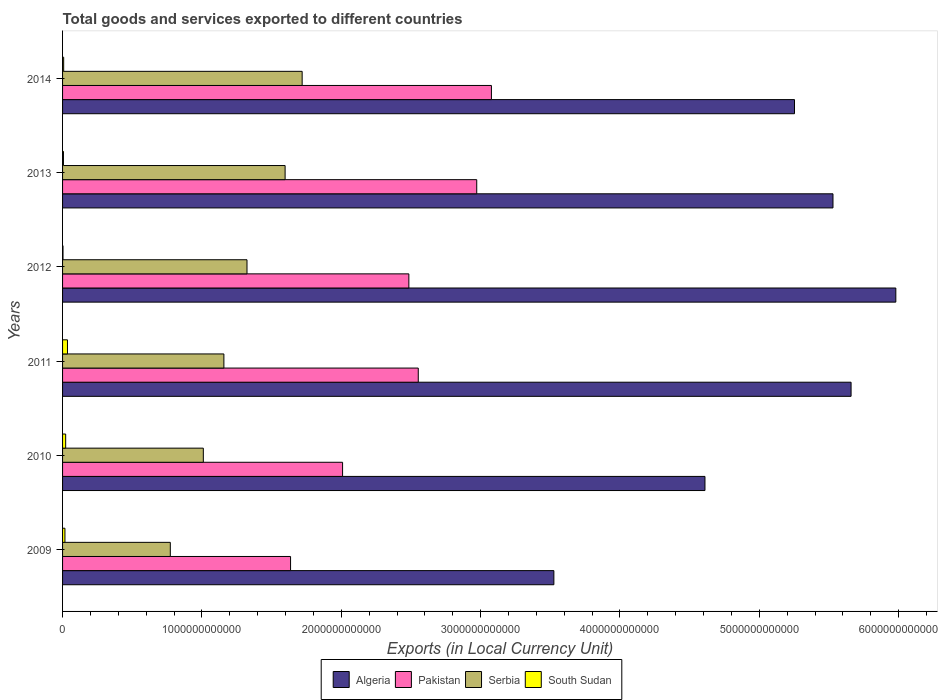How many different coloured bars are there?
Provide a short and direct response. 4. How many groups of bars are there?
Keep it short and to the point. 6. Are the number of bars per tick equal to the number of legend labels?
Your answer should be very brief. Yes. Are the number of bars on each tick of the Y-axis equal?
Ensure brevity in your answer.  Yes. How many bars are there on the 1st tick from the top?
Keep it short and to the point. 4. What is the label of the 6th group of bars from the top?
Make the answer very short. 2009. In how many cases, is the number of bars for a given year not equal to the number of legend labels?
Provide a succinct answer. 0. What is the Amount of goods and services exports in South Sudan in 2014?
Provide a short and direct response. 7.90e+09. Across all years, what is the maximum Amount of goods and services exports in Algeria?
Ensure brevity in your answer.  5.98e+12. Across all years, what is the minimum Amount of goods and services exports in South Sudan?
Your answer should be very brief. 3.10e+09. In which year was the Amount of goods and services exports in Serbia minimum?
Give a very brief answer. 2009. What is the total Amount of goods and services exports in Algeria in the graph?
Give a very brief answer. 3.06e+13. What is the difference between the Amount of goods and services exports in Pakistan in 2009 and that in 2014?
Provide a short and direct response. -1.44e+12. What is the difference between the Amount of goods and services exports in South Sudan in 2013 and the Amount of goods and services exports in Serbia in 2012?
Offer a very short reply. -1.32e+12. What is the average Amount of goods and services exports in Pakistan per year?
Provide a short and direct response. 2.46e+12. In the year 2009, what is the difference between the Amount of goods and services exports in Algeria and Amount of goods and services exports in Pakistan?
Give a very brief answer. 1.89e+12. What is the ratio of the Amount of goods and services exports in South Sudan in 2011 to that in 2014?
Your response must be concise. 4.46. Is the difference between the Amount of goods and services exports in Algeria in 2010 and 2013 greater than the difference between the Amount of goods and services exports in Pakistan in 2010 and 2013?
Your response must be concise. Yes. What is the difference between the highest and the second highest Amount of goods and services exports in Serbia?
Your answer should be compact. 1.22e+11. What is the difference between the highest and the lowest Amount of goods and services exports in South Sudan?
Keep it short and to the point. 3.21e+1. In how many years, is the Amount of goods and services exports in South Sudan greater than the average Amount of goods and services exports in South Sudan taken over all years?
Provide a short and direct response. 3. Is it the case that in every year, the sum of the Amount of goods and services exports in Pakistan and Amount of goods and services exports in Algeria is greater than the sum of Amount of goods and services exports in Serbia and Amount of goods and services exports in South Sudan?
Keep it short and to the point. Yes. What does the 1st bar from the top in 2010 represents?
Give a very brief answer. South Sudan. What does the 1st bar from the bottom in 2009 represents?
Offer a very short reply. Algeria. How many bars are there?
Keep it short and to the point. 24. How many years are there in the graph?
Your answer should be compact. 6. What is the difference between two consecutive major ticks on the X-axis?
Provide a short and direct response. 1.00e+12. Are the values on the major ticks of X-axis written in scientific E-notation?
Your answer should be compact. No. Does the graph contain any zero values?
Make the answer very short. No. Does the graph contain grids?
Your answer should be very brief. No. Where does the legend appear in the graph?
Give a very brief answer. Bottom center. How are the legend labels stacked?
Give a very brief answer. Horizontal. What is the title of the graph?
Ensure brevity in your answer.  Total goods and services exported to different countries. What is the label or title of the X-axis?
Your response must be concise. Exports (in Local Currency Unit). What is the label or title of the Y-axis?
Your answer should be compact. Years. What is the Exports (in Local Currency Unit) of Algeria in 2009?
Provide a succinct answer. 3.53e+12. What is the Exports (in Local Currency Unit) in Pakistan in 2009?
Your response must be concise. 1.64e+12. What is the Exports (in Local Currency Unit) in Serbia in 2009?
Your answer should be compact. 7.73e+11. What is the Exports (in Local Currency Unit) of South Sudan in 2009?
Your response must be concise. 1.70e+1. What is the Exports (in Local Currency Unit) in Algeria in 2010?
Your answer should be very brief. 4.61e+12. What is the Exports (in Local Currency Unit) in Pakistan in 2010?
Your answer should be very brief. 2.01e+12. What is the Exports (in Local Currency Unit) in Serbia in 2010?
Make the answer very short. 1.01e+12. What is the Exports (in Local Currency Unit) of South Sudan in 2010?
Provide a short and direct response. 2.23e+1. What is the Exports (in Local Currency Unit) in Algeria in 2011?
Make the answer very short. 5.66e+12. What is the Exports (in Local Currency Unit) of Pakistan in 2011?
Keep it short and to the point. 2.55e+12. What is the Exports (in Local Currency Unit) in Serbia in 2011?
Your answer should be very brief. 1.16e+12. What is the Exports (in Local Currency Unit) of South Sudan in 2011?
Make the answer very short. 3.52e+1. What is the Exports (in Local Currency Unit) of Algeria in 2012?
Give a very brief answer. 5.98e+12. What is the Exports (in Local Currency Unit) in Pakistan in 2012?
Offer a very short reply. 2.49e+12. What is the Exports (in Local Currency Unit) of Serbia in 2012?
Provide a succinct answer. 1.32e+12. What is the Exports (in Local Currency Unit) of South Sudan in 2012?
Provide a short and direct response. 3.10e+09. What is the Exports (in Local Currency Unit) in Algeria in 2013?
Offer a terse response. 5.53e+12. What is the Exports (in Local Currency Unit) of Pakistan in 2013?
Make the answer very short. 2.97e+12. What is the Exports (in Local Currency Unit) in Serbia in 2013?
Keep it short and to the point. 1.60e+12. What is the Exports (in Local Currency Unit) of South Sudan in 2013?
Make the answer very short. 6.33e+09. What is the Exports (in Local Currency Unit) of Algeria in 2014?
Your answer should be compact. 5.25e+12. What is the Exports (in Local Currency Unit) of Pakistan in 2014?
Make the answer very short. 3.08e+12. What is the Exports (in Local Currency Unit) of Serbia in 2014?
Ensure brevity in your answer.  1.72e+12. What is the Exports (in Local Currency Unit) of South Sudan in 2014?
Your answer should be compact. 7.90e+09. Across all years, what is the maximum Exports (in Local Currency Unit) in Algeria?
Keep it short and to the point. 5.98e+12. Across all years, what is the maximum Exports (in Local Currency Unit) in Pakistan?
Offer a very short reply. 3.08e+12. Across all years, what is the maximum Exports (in Local Currency Unit) in Serbia?
Give a very brief answer. 1.72e+12. Across all years, what is the maximum Exports (in Local Currency Unit) of South Sudan?
Offer a terse response. 3.52e+1. Across all years, what is the minimum Exports (in Local Currency Unit) in Algeria?
Your answer should be compact. 3.53e+12. Across all years, what is the minimum Exports (in Local Currency Unit) in Pakistan?
Your answer should be compact. 1.64e+12. Across all years, what is the minimum Exports (in Local Currency Unit) of Serbia?
Make the answer very short. 7.73e+11. Across all years, what is the minimum Exports (in Local Currency Unit) in South Sudan?
Provide a succinct answer. 3.10e+09. What is the total Exports (in Local Currency Unit) in Algeria in the graph?
Your answer should be very brief. 3.06e+13. What is the total Exports (in Local Currency Unit) of Pakistan in the graph?
Your answer should be compact. 1.47e+13. What is the total Exports (in Local Currency Unit) of Serbia in the graph?
Your answer should be compact. 7.58e+12. What is the total Exports (in Local Currency Unit) in South Sudan in the graph?
Provide a short and direct response. 9.18e+1. What is the difference between the Exports (in Local Currency Unit) of Algeria in 2009 and that in 2010?
Keep it short and to the point. -1.08e+12. What is the difference between the Exports (in Local Currency Unit) of Pakistan in 2009 and that in 2010?
Offer a very short reply. -3.73e+11. What is the difference between the Exports (in Local Currency Unit) of Serbia in 2009 and that in 2010?
Offer a terse response. -2.37e+11. What is the difference between the Exports (in Local Currency Unit) of South Sudan in 2009 and that in 2010?
Give a very brief answer. -5.23e+09. What is the difference between the Exports (in Local Currency Unit) in Algeria in 2009 and that in 2011?
Your answer should be very brief. -2.13e+12. What is the difference between the Exports (in Local Currency Unit) in Pakistan in 2009 and that in 2011?
Make the answer very short. -9.16e+11. What is the difference between the Exports (in Local Currency Unit) in Serbia in 2009 and that in 2011?
Your answer should be compact. -3.85e+11. What is the difference between the Exports (in Local Currency Unit) of South Sudan in 2009 and that in 2011?
Provide a succinct answer. -1.82e+1. What is the difference between the Exports (in Local Currency Unit) of Algeria in 2009 and that in 2012?
Your response must be concise. -2.45e+12. What is the difference between the Exports (in Local Currency Unit) of Pakistan in 2009 and that in 2012?
Your response must be concise. -8.49e+11. What is the difference between the Exports (in Local Currency Unit) of Serbia in 2009 and that in 2012?
Your answer should be very brief. -5.50e+11. What is the difference between the Exports (in Local Currency Unit) in South Sudan in 2009 and that in 2012?
Ensure brevity in your answer.  1.39e+1. What is the difference between the Exports (in Local Currency Unit) in Algeria in 2009 and that in 2013?
Your response must be concise. -2.00e+12. What is the difference between the Exports (in Local Currency Unit) of Pakistan in 2009 and that in 2013?
Offer a very short reply. -1.34e+12. What is the difference between the Exports (in Local Currency Unit) in Serbia in 2009 and that in 2013?
Provide a short and direct response. -8.24e+11. What is the difference between the Exports (in Local Currency Unit) of South Sudan in 2009 and that in 2013?
Your response must be concise. 1.07e+1. What is the difference between the Exports (in Local Currency Unit) of Algeria in 2009 and that in 2014?
Provide a succinct answer. -1.73e+12. What is the difference between the Exports (in Local Currency Unit) in Pakistan in 2009 and that in 2014?
Your answer should be compact. -1.44e+12. What is the difference between the Exports (in Local Currency Unit) in Serbia in 2009 and that in 2014?
Your answer should be compact. -9.46e+11. What is the difference between the Exports (in Local Currency Unit) of South Sudan in 2009 and that in 2014?
Offer a very short reply. 9.14e+09. What is the difference between the Exports (in Local Currency Unit) of Algeria in 2010 and that in 2011?
Ensure brevity in your answer.  -1.05e+12. What is the difference between the Exports (in Local Currency Unit) of Pakistan in 2010 and that in 2011?
Provide a succinct answer. -5.43e+11. What is the difference between the Exports (in Local Currency Unit) of Serbia in 2010 and that in 2011?
Give a very brief answer. -1.48e+11. What is the difference between the Exports (in Local Currency Unit) of South Sudan in 2010 and that in 2011?
Provide a succinct answer. -1.29e+1. What is the difference between the Exports (in Local Currency Unit) in Algeria in 2010 and that in 2012?
Offer a very short reply. -1.37e+12. What is the difference between the Exports (in Local Currency Unit) in Pakistan in 2010 and that in 2012?
Keep it short and to the point. -4.76e+11. What is the difference between the Exports (in Local Currency Unit) in Serbia in 2010 and that in 2012?
Provide a succinct answer. -3.13e+11. What is the difference between the Exports (in Local Currency Unit) of South Sudan in 2010 and that in 2012?
Ensure brevity in your answer.  1.92e+1. What is the difference between the Exports (in Local Currency Unit) of Algeria in 2010 and that in 2013?
Make the answer very short. -9.19e+11. What is the difference between the Exports (in Local Currency Unit) of Pakistan in 2010 and that in 2013?
Offer a terse response. -9.63e+11. What is the difference between the Exports (in Local Currency Unit) of Serbia in 2010 and that in 2013?
Provide a short and direct response. -5.87e+11. What is the difference between the Exports (in Local Currency Unit) of South Sudan in 2010 and that in 2013?
Provide a short and direct response. 1.59e+1. What is the difference between the Exports (in Local Currency Unit) of Algeria in 2010 and that in 2014?
Offer a very short reply. -6.42e+11. What is the difference between the Exports (in Local Currency Unit) in Pakistan in 2010 and that in 2014?
Make the answer very short. -1.07e+12. What is the difference between the Exports (in Local Currency Unit) of Serbia in 2010 and that in 2014?
Your response must be concise. -7.09e+11. What is the difference between the Exports (in Local Currency Unit) in South Sudan in 2010 and that in 2014?
Keep it short and to the point. 1.44e+1. What is the difference between the Exports (in Local Currency Unit) in Algeria in 2011 and that in 2012?
Provide a succinct answer. -3.21e+11. What is the difference between the Exports (in Local Currency Unit) in Pakistan in 2011 and that in 2012?
Provide a short and direct response. 6.75e+1. What is the difference between the Exports (in Local Currency Unit) in Serbia in 2011 and that in 2012?
Provide a succinct answer. -1.66e+11. What is the difference between the Exports (in Local Currency Unit) of South Sudan in 2011 and that in 2012?
Your answer should be very brief. 3.21e+1. What is the difference between the Exports (in Local Currency Unit) in Algeria in 2011 and that in 2013?
Make the answer very short. 1.30e+11. What is the difference between the Exports (in Local Currency Unit) of Pakistan in 2011 and that in 2013?
Give a very brief answer. -4.20e+11. What is the difference between the Exports (in Local Currency Unit) of Serbia in 2011 and that in 2013?
Give a very brief answer. -4.39e+11. What is the difference between the Exports (in Local Currency Unit) of South Sudan in 2011 and that in 2013?
Your answer should be compact. 2.89e+1. What is the difference between the Exports (in Local Currency Unit) of Algeria in 2011 and that in 2014?
Your response must be concise. 4.06e+11. What is the difference between the Exports (in Local Currency Unit) in Pakistan in 2011 and that in 2014?
Provide a succinct answer. -5.25e+11. What is the difference between the Exports (in Local Currency Unit) in Serbia in 2011 and that in 2014?
Offer a very short reply. -5.62e+11. What is the difference between the Exports (in Local Currency Unit) in South Sudan in 2011 and that in 2014?
Your answer should be compact. 2.73e+1. What is the difference between the Exports (in Local Currency Unit) in Algeria in 2012 and that in 2013?
Keep it short and to the point. 4.51e+11. What is the difference between the Exports (in Local Currency Unit) in Pakistan in 2012 and that in 2013?
Offer a very short reply. -4.87e+11. What is the difference between the Exports (in Local Currency Unit) of Serbia in 2012 and that in 2013?
Your response must be concise. -2.73e+11. What is the difference between the Exports (in Local Currency Unit) of South Sudan in 2012 and that in 2013?
Provide a short and direct response. -3.24e+09. What is the difference between the Exports (in Local Currency Unit) in Algeria in 2012 and that in 2014?
Ensure brevity in your answer.  7.27e+11. What is the difference between the Exports (in Local Currency Unit) in Pakistan in 2012 and that in 2014?
Make the answer very short. -5.93e+11. What is the difference between the Exports (in Local Currency Unit) in Serbia in 2012 and that in 2014?
Your response must be concise. -3.96e+11. What is the difference between the Exports (in Local Currency Unit) of South Sudan in 2012 and that in 2014?
Provide a short and direct response. -4.80e+09. What is the difference between the Exports (in Local Currency Unit) of Algeria in 2013 and that in 2014?
Provide a succinct answer. 2.76e+11. What is the difference between the Exports (in Local Currency Unit) of Pakistan in 2013 and that in 2014?
Offer a very short reply. -1.05e+11. What is the difference between the Exports (in Local Currency Unit) of Serbia in 2013 and that in 2014?
Your response must be concise. -1.22e+11. What is the difference between the Exports (in Local Currency Unit) of South Sudan in 2013 and that in 2014?
Your response must be concise. -1.56e+09. What is the difference between the Exports (in Local Currency Unit) in Algeria in 2009 and the Exports (in Local Currency Unit) in Pakistan in 2010?
Give a very brief answer. 1.52e+12. What is the difference between the Exports (in Local Currency Unit) in Algeria in 2009 and the Exports (in Local Currency Unit) in Serbia in 2010?
Your response must be concise. 2.52e+12. What is the difference between the Exports (in Local Currency Unit) of Algeria in 2009 and the Exports (in Local Currency Unit) of South Sudan in 2010?
Provide a short and direct response. 3.50e+12. What is the difference between the Exports (in Local Currency Unit) in Pakistan in 2009 and the Exports (in Local Currency Unit) in Serbia in 2010?
Provide a short and direct response. 6.26e+11. What is the difference between the Exports (in Local Currency Unit) in Pakistan in 2009 and the Exports (in Local Currency Unit) in South Sudan in 2010?
Make the answer very short. 1.61e+12. What is the difference between the Exports (in Local Currency Unit) in Serbia in 2009 and the Exports (in Local Currency Unit) in South Sudan in 2010?
Your answer should be compact. 7.51e+11. What is the difference between the Exports (in Local Currency Unit) in Algeria in 2009 and the Exports (in Local Currency Unit) in Pakistan in 2011?
Your answer should be very brief. 9.73e+11. What is the difference between the Exports (in Local Currency Unit) of Algeria in 2009 and the Exports (in Local Currency Unit) of Serbia in 2011?
Provide a succinct answer. 2.37e+12. What is the difference between the Exports (in Local Currency Unit) in Algeria in 2009 and the Exports (in Local Currency Unit) in South Sudan in 2011?
Your answer should be compact. 3.49e+12. What is the difference between the Exports (in Local Currency Unit) of Pakistan in 2009 and the Exports (in Local Currency Unit) of Serbia in 2011?
Give a very brief answer. 4.78e+11. What is the difference between the Exports (in Local Currency Unit) in Pakistan in 2009 and the Exports (in Local Currency Unit) in South Sudan in 2011?
Your answer should be very brief. 1.60e+12. What is the difference between the Exports (in Local Currency Unit) of Serbia in 2009 and the Exports (in Local Currency Unit) of South Sudan in 2011?
Keep it short and to the point. 7.38e+11. What is the difference between the Exports (in Local Currency Unit) of Algeria in 2009 and the Exports (in Local Currency Unit) of Pakistan in 2012?
Make the answer very short. 1.04e+12. What is the difference between the Exports (in Local Currency Unit) of Algeria in 2009 and the Exports (in Local Currency Unit) of Serbia in 2012?
Provide a short and direct response. 2.20e+12. What is the difference between the Exports (in Local Currency Unit) in Algeria in 2009 and the Exports (in Local Currency Unit) in South Sudan in 2012?
Your answer should be very brief. 3.52e+12. What is the difference between the Exports (in Local Currency Unit) in Pakistan in 2009 and the Exports (in Local Currency Unit) in Serbia in 2012?
Provide a short and direct response. 3.13e+11. What is the difference between the Exports (in Local Currency Unit) of Pakistan in 2009 and the Exports (in Local Currency Unit) of South Sudan in 2012?
Keep it short and to the point. 1.63e+12. What is the difference between the Exports (in Local Currency Unit) in Serbia in 2009 and the Exports (in Local Currency Unit) in South Sudan in 2012?
Offer a terse response. 7.70e+11. What is the difference between the Exports (in Local Currency Unit) of Algeria in 2009 and the Exports (in Local Currency Unit) of Pakistan in 2013?
Keep it short and to the point. 5.54e+11. What is the difference between the Exports (in Local Currency Unit) of Algeria in 2009 and the Exports (in Local Currency Unit) of Serbia in 2013?
Offer a terse response. 1.93e+12. What is the difference between the Exports (in Local Currency Unit) in Algeria in 2009 and the Exports (in Local Currency Unit) in South Sudan in 2013?
Provide a short and direct response. 3.52e+12. What is the difference between the Exports (in Local Currency Unit) in Pakistan in 2009 and the Exports (in Local Currency Unit) in Serbia in 2013?
Offer a terse response. 3.91e+1. What is the difference between the Exports (in Local Currency Unit) in Pakistan in 2009 and the Exports (in Local Currency Unit) in South Sudan in 2013?
Your answer should be very brief. 1.63e+12. What is the difference between the Exports (in Local Currency Unit) in Serbia in 2009 and the Exports (in Local Currency Unit) in South Sudan in 2013?
Provide a succinct answer. 7.67e+11. What is the difference between the Exports (in Local Currency Unit) in Algeria in 2009 and the Exports (in Local Currency Unit) in Pakistan in 2014?
Your answer should be compact. 4.48e+11. What is the difference between the Exports (in Local Currency Unit) in Algeria in 2009 and the Exports (in Local Currency Unit) in Serbia in 2014?
Give a very brief answer. 1.81e+12. What is the difference between the Exports (in Local Currency Unit) in Algeria in 2009 and the Exports (in Local Currency Unit) in South Sudan in 2014?
Keep it short and to the point. 3.52e+12. What is the difference between the Exports (in Local Currency Unit) in Pakistan in 2009 and the Exports (in Local Currency Unit) in Serbia in 2014?
Offer a very short reply. -8.31e+1. What is the difference between the Exports (in Local Currency Unit) of Pakistan in 2009 and the Exports (in Local Currency Unit) of South Sudan in 2014?
Your answer should be very brief. 1.63e+12. What is the difference between the Exports (in Local Currency Unit) of Serbia in 2009 and the Exports (in Local Currency Unit) of South Sudan in 2014?
Give a very brief answer. 7.65e+11. What is the difference between the Exports (in Local Currency Unit) of Algeria in 2010 and the Exports (in Local Currency Unit) of Pakistan in 2011?
Provide a succinct answer. 2.06e+12. What is the difference between the Exports (in Local Currency Unit) in Algeria in 2010 and the Exports (in Local Currency Unit) in Serbia in 2011?
Keep it short and to the point. 3.45e+12. What is the difference between the Exports (in Local Currency Unit) in Algeria in 2010 and the Exports (in Local Currency Unit) in South Sudan in 2011?
Ensure brevity in your answer.  4.57e+12. What is the difference between the Exports (in Local Currency Unit) in Pakistan in 2010 and the Exports (in Local Currency Unit) in Serbia in 2011?
Provide a short and direct response. 8.52e+11. What is the difference between the Exports (in Local Currency Unit) in Pakistan in 2010 and the Exports (in Local Currency Unit) in South Sudan in 2011?
Your answer should be very brief. 1.97e+12. What is the difference between the Exports (in Local Currency Unit) of Serbia in 2010 and the Exports (in Local Currency Unit) of South Sudan in 2011?
Offer a very short reply. 9.75e+11. What is the difference between the Exports (in Local Currency Unit) of Algeria in 2010 and the Exports (in Local Currency Unit) of Pakistan in 2012?
Provide a succinct answer. 2.13e+12. What is the difference between the Exports (in Local Currency Unit) of Algeria in 2010 and the Exports (in Local Currency Unit) of Serbia in 2012?
Make the answer very short. 3.29e+12. What is the difference between the Exports (in Local Currency Unit) of Algeria in 2010 and the Exports (in Local Currency Unit) of South Sudan in 2012?
Ensure brevity in your answer.  4.61e+12. What is the difference between the Exports (in Local Currency Unit) in Pakistan in 2010 and the Exports (in Local Currency Unit) in Serbia in 2012?
Provide a succinct answer. 6.86e+11. What is the difference between the Exports (in Local Currency Unit) of Pakistan in 2010 and the Exports (in Local Currency Unit) of South Sudan in 2012?
Keep it short and to the point. 2.01e+12. What is the difference between the Exports (in Local Currency Unit) of Serbia in 2010 and the Exports (in Local Currency Unit) of South Sudan in 2012?
Provide a short and direct response. 1.01e+12. What is the difference between the Exports (in Local Currency Unit) in Algeria in 2010 and the Exports (in Local Currency Unit) in Pakistan in 2013?
Make the answer very short. 1.64e+12. What is the difference between the Exports (in Local Currency Unit) of Algeria in 2010 and the Exports (in Local Currency Unit) of Serbia in 2013?
Offer a very short reply. 3.01e+12. What is the difference between the Exports (in Local Currency Unit) in Algeria in 2010 and the Exports (in Local Currency Unit) in South Sudan in 2013?
Give a very brief answer. 4.60e+12. What is the difference between the Exports (in Local Currency Unit) in Pakistan in 2010 and the Exports (in Local Currency Unit) in Serbia in 2013?
Offer a very short reply. 4.12e+11. What is the difference between the Exports (in Local Currency Unit) in Pakistan in 2010 and the Exports (in Local Currency Unit) in South Sudan in 2013?
Make the answer very short. 2.00e+12. What is the difference between the Exports (in Local Currency Unit) in Serbia in 2010 and the Exports (in Local Currency Unit) in South Sudan in 2013?
Your answer should be very brief. 1.00e+12. What is the difference between the Exports (in Local Currency Unit) in Algeria in 2010 and the Exports (in Local Currency Unit) in Pakistan in 2014?
Offer a terse response. 1.53e+12. What is the difference between the Exports (in Local Currency Unit) of Algeria in 2010 and the Exports (in Local Currency Unit) of Serbia in 2014?
Give a very brief answer. 2.89e+12. What is the difference between the Exports (in Local Currency Unit) of Algeria in 2010 and the Exports (in Local Currency Unit) of South Sudan in 2014?
Your response must be concise. 4.60e+12. What is the difference between the Exports (in Local Currency Unit) in Pakistan in 2010 and the Exports (in Local Currency Unit) in Serbia in 2014?
Provide a short and direct response. 2.90e+11. What is the difference between the Exports (in Local Currency Unit) of Pakistan in 2010 and the Exports (in Local Currency Unit) of South Sudan in 2014?
Offer a terse response. 2.00e+12. What is the difference between the Exports (in Local Currency Unit) of Serbia in 2010 and the Exports (in Local Currency Unit) of South Sudan in 2014?
Provide a short and direct response. 1.00e+12. What is the difference between the Exports (in Local Currency Unit) in Algeria in 2011 and the Exports (in Local Currency Unit) in Pakistan in 2012?
Offer a very short reply. 3.17e+12. What is the difference between the Exports (in Local Currency Unit) of Algeria in 2011 and the Exports (in Local Currency Unit) of Serbia in 2012?
Ensure brevity in your answer.  4.34e+12. What is the difference between the Exports (in Local Currency Unit) in Algeria in 2011 and the Exports (in Local Currency Unit) in South Sudan in 2012?
Provide a short and direct response. 5.66e+12. What is the difference between the Exports (in Local Currency Unit) in Pakistan in 2011 and the Exports (in Local Currency Unit) in Serbia in 2012?
Give a very brief answer. 1.23e+12. What is the difference between the Exports (in Local Currency Unit) of Pakistan in 2011 and the Exports (in Local Currency Unit) of South Sudan in 2012?
Offer a very short reply. 2.55e+12. What is the difference between the Exports (in Local Currency Unit) in Serbia in 2011 and the Exports (in Local Currency Unit) in South Sudan in 2012?
Your answer should be compact. 1.15e+12. What is the difference between the Exports (in Local Currency Unit) in Algeria in 2011 and the Exports (in Local Currency Unit) in Pakistan in 2013?
Offer a very short reply. 2.69e+12. What is the difference between the Exports (in Local Currency Unit) in Algeria in 2011 and the Exports (in Local Currency Unit) in Serbia in 2013?
Make the answer very short. 4.06e+12. What is the difference between the Exports (in Local Currency Unit) in Algeria in 2011 and the Exports (in Local Currency Unit) in South Sudan in 2013?
Give a very brief answer. 5.65e+12. What is the difference between the Exports (in Local Currency Unit) of Pakistan in 2011 and the Exports (in Local Currency Unit) of Serbia in 2013?
Offer a terse response. 9.56e+11. What is the difference between the Exports (in Local Currency Unit) of Pakistan in 2011 and the Exports (in Local Currency Unit) of South Sudan in 2013?
Provide a short and direct response. 2.55e+12. What is the difference between the Exports (in Local Currency Unit) of Serbia in 2011 and the Exports (in Local Currency Unit) of South Sudan in 2013?
Your answer should be compact. 1.15e+12. What is the difference between the Exports (in Local Currency Unit) in Algeria in 2011 and the Exports (in Local Currency Unit) in Pakistan in 2014?
Make the answer very short. 2.58e+12. What is the difference between the Exports (in Local Currency Unit) in Algeria in 2011 and the Exports (in Local Currency Unit) in Serbia in 2014?
Provide a succinct answer. 3.94e+12. What is the difference between the Exports (in Local Currency Unit) of Algeria in 2011 and the Exports (in Local Currency Unit) of South Sudan in 2014?
Your answer should be compact. 5.65e+12. What is the difference between the Exports (in Local Currency Unit) of Pakistan in 2011 and the Exports (in Local Currency Unit) of Serbia in 2014?
Ensure brevity in your answer.  8.33e+11. What is the difference between the Exports (in Local Currency Unit) of Pakistan in 2011 and the Exports (in Local Currency Unit) of South Sudan in 2014?
Keep it short and to the point. 2.54e+12. What is the difference between the Exports (in Local Currency Unit) of Serbia in 2011 and the Exports (in Local Currency Unit) of South Sudan in 2014?
Give a very brief answer. 1.15e+12. What is the difference between the Exports (in Local Currency Unit) in Algeria in 2012 and the Exports (in Local Currency Unit) in Pakistan in 2013?
Provide a succinct answer. 3.01e+12. What is the difference between the Exports (in Local Currency Unit) of Algeria in 2012 and the Exports (in Local Currency Unit) of Serbia in 2013?
Make the answer very short. 4.38e+12. What is the difference between the Exports (in Local Currency Unit) in Algeria in 2012 and the Exports (in Local Currency Unit) in South Sudan in 2013?
Keep it short and to the point. 5.97e+12. What is the difference between the Exports (in Local Currency Unit) of Pakistan in 2012 and the Exports (in Local Currency Unit) of Serbia in 2013?
Provide a succinct answer. 8.88e+11. What is the difference between the Exports (in Local Currency Unit) in Pakistan in 2012 and the Exports (in Local Currency Unit) in South Sudan in 2013?
Offer a very short reply. 2.48e+12. What is the difference between the Exports (in Local Currency Unit) of Serbia in 2012 and the Exports (in Local Currency Unit) of South Sudan in 2013?
Make the answer very short. 1.32e+12. What is the difference between the Exports (in Local Currency Unit) in Algeria in 2012 and the Exports (in Local Currency Unit) in Pakistan in 2014?
Ensure brevity in your answer.  2.90e+12. What is the difference between the Exports (in Local Currency Unit) in Algeria in 2012 and the Exports (in Local Currency Unit) in Serbia in 2014?
Your response must be concise. 4.26e+12. What is the difference between the Exports (in Local Currency Unit) in Algeria in 2012 and the Exports (in Local Currency Unit) in South Sudan in 2014?
Make the answer very short. 5.97e+12. What is the difference between the Exports (in Local Currency Unit) of Pakistan in 2012 and the Exports (in Local Currency Unit) of Serbia in 2014?
Give a very brief answer. 7.66e+11. What is the difference between the Exports (in Local Currency Unit) of Pakistan in 2012 and the Exports (in Local Currency Unit) of South Sudan in 2014?
Your response must be concise. 2.48e+12. What is the difference between the Exports (in Local Currency Unit) in Serbia in 2012 and the Exports (in Local Currency Unit) in South Sudan in 2014?
Offer a terse response. 1.32e+12. What is the difference between the Exports (in Local Currency Unit) of Algeria in 2013 and the Exports (in Local Currency Unit) of Pakistan in 2014?
Make the answer very short. 2.45e+12. What is the difference between the Exports (in Local Currency Unit) of Algeria in 2013 and the Exports (in Local Currency Unit) of Serbia in 2014?
Ensure brevity in your answer.  3.81e+12. What is the difference between the Exports (in Local Currency Unit) of Algeria in 2013 and the Exports (in Local Currency Unit) of South Sudan in 2014?
Your answer should be very brief. 5.52e+12. What is the difference between the Exports (in Local Currency Unit) of Pakistan in 2013 and the Exports (in Local Currency Unit) of Serbia in 2014?
Ensure brevity in your answer.  1.25e+12. What is the difference between the Exports (in Local Currency Unit) in Pakistan in 2013 and the Exports (in Local Currency Unit) in South Sudan in 2014?
Offer a terse response. 2.96e+12. What is the difference between the Exports (in Local Currency Unit) in Serbia in 2013 and the Exports (in Local Currency Unit) in South Sudan in 2014?
Keep it short and to the point. 1.59e+12. What is the average Exports (in Local Currency Unit) in Algeria per year?
Make the answer very short. 5.09e+12. What is the average Exports (in Local Currency Unit) of Pakistan per year?
Offer a very short reply. 2.46e+12. What is the average Exports (in Local Currency Unit) in Serbia per year?
Provide a short and direct response. 1.26e+12. What is the average Exports (in Local Currency Unit) of South Sudan per year?
Offer a terse response. 1.53e+1. In the year 2009, what is the difference between the Exports (in Local Currency Unit) in Algeria and Exports (in Local Currency Unit) in Pakistan?
Your answer should be very brief. 1.89e+12. In the year 2009, what is the difference between the Exports (in Local Currency Unit) in Algeria and Exports (in Local Currency Unit) in Serbia?
Offer a very short reply. 2.75e+12. In the year 2009, what is the difference between the Exports (in Local Currency Unit) of Algeria and Exports (in Local Currency Unit) of South Sudan?
Your response must be concise. 3.51e+12. In the year 2009, what is the difference between the Exports (in Local Currency Unit) of Pakistan and Exports (in Local Currency Unit) of Serbia?
Ensure brevity in your answer.  8.63e+11. In the year 2009, what is the difference between the Exports (in Local Currency Unit) of Pakistan and Exports (in Local Currency Unit) of South Sudan?
Offer a terse response. 1.62e+12. In the year 2009, what is the difference between the Exports (in Local Currency Unit) of Serbia and Exports (in Local Currency Unit) of South Sudan?
Keep it short and to the point. 7.56e+11. In the year 2010, what is the difference between the Exports (in Local Currency Unit) in Algeria and Exports (in Local Currency Unit) in Pakistan?
Provide a succinct answer. 2.60e+12. In the year 2010, what is the difference between the Exports (in Local Currency Unit) in Algeria and Exports (in Local Currency Unit) in Serbia?
Provide a short and direct response. 3.60e+12. In the year 2010, what is the difference between the Exports (in Local Currency Unit) in Algeria and Exports (in Local Currency Unit) in South Sudan?
Offer a terse response. 4.59e+12. In the year 2010, what is the difference between the Exports (in Local Currency Unit) in Pakistan and Exports (in Local Currency Unit) in Serbia?
Your response must be concise. 9.99e+11. In the year 2010, what is the difference between the Exports (in Local Currency Unit) in Pakistan and Exports (in Local Currency Unit) in South Sudan?
Your answer should be compact. 1.99e+12. In the year 2010, what is the difference between the Exports (in Local Currency Unit) in Serbia and Exports (in Local Currency Unit) in South Sudan?
Your response must be concise. 9.88e+11. In the year 2011, what is the difference between the Exports (in Local Currency Unit) in Algeria and Exports (in Local Currency Unit) in Pakistan?
Your answer should be compact. 3.11e+12. In the year 2011, what is the difference between the Exports (in Local Currency Unit) of Algeria and Exports (in Local Currency Unit) of Serbia?
Offer a terse response. 4.50e+12. In the year 2011, what is the difference between the Exports (in Local Currency Unit) in Algeria and Exports (in Local Currency Unit) in South Sudan?
Your answer should be very brief. 5.62e+12. In the year 2011, what is the difference between the Exports (in Local Currency Unit) in Pakistan and Exports (in Local Currency Unit) in Serbia?
Make the answer very short. 1.39e+12. In the year 2011, what is the difference between the Exports (in Local Currency Unit) in Pakistan and Exports (in Local Currency Unit) in South Sudan?
Offer a terse response. 2.52e+12. In the year 2011, what is the difference between the Exports (in Local Currency Unit) of Serbia and Exports (in Local Currency Unit) of South Sudan?
Offer a terse response. 1.12e+12. In the year 2012, what is the difference between the Exports (in Local Currency Unit) in Algeria and Exports (in Local Currency Unit) in Pakistan?
Offer a terse response. 3.49e+12. In the year 2012, what is the difference between the Exports (in Local Currency Unit) of Algeria and Exports (in Local Currency Unit) of Serbia?
Your response must be concise. 4.66e+12. In the year 2012, what is the difference between the Exports (in Local Currency Unit) of Algeria and Exports (in Local Currency Unit) of South Sudan?
Your response must be concise. 5.98e+12. In the year 2012, what is the difference between the Exports (in Local Currency Unit) in Pakistan and Exports (in Local Currency Unit) in Serbia?
Give a very brief answer. 1.16e+12. In the year 2012, what is the difference between the Exports (in Local Currency Unit) in Pakistan and Exports (in Local Currency Unit) in South Sudan?
Offer a terse response. 2.48e+12. In the year 2012, what is the difference between the Exports (in Local Currency Unit) of Serbia and Exports (in Local Currency Unit) of South Sudan?
Your answer should be very brief. 1.32e+12. In the year 2013, what is the difference between the Exports (in Local Currency Unit) of Algeria and Exports (in Local Currency Unit) of Pakistan?
Your answer should be very brief. 2.56e+12. In the year 2013, what is the difference between the Exports (in Local Currency Unit) in Algeria and Exports (in Local Currency Unit) in Serbia?
Your answer should be compact. 3.93e+12. In the year 2013, what is the difference between the Exports (in Local Currency Unit) in Algeria and Exports (in Local Currency Unit) in South Sudan?
Give a very brief answer. 5.52e+12. In the year 2013, what is the difference between the Exports (in Local Currency Unit) of Pakistan and Exports (in Local Currency Unit) of Serbia?
Offer a very short reply. 1.38e+12. In the year 2013, what is the difference between the Exports (in Local Currency Unit) of Pakistan and Exports (in Local Currency Unit) of South Sudan?
Keep it short and to the point. 2.97e+12. In the year 2013, what is the difference between the Exports (in Local Currency Unit) in Serbia and Exports (in Local Currency Unit) in South Sudan?
Make the answer very short. 1.59e+12. In the year 2014, what is the difference between the Exports (in Local Currency Unit) in Algeria and Exports (in Local Currency Unit) in Pakistan?
Your answer should be compact. 2.17e+12. In the year 2014, what is the difference between the Exports (in Local Currency Unit) of Algeria and Exports (in Local Currency Unit) of Serbia?
Your answer should be very brief. 3.53e+12. In the year 2014, what is the difference between the Exports (in Local Currency Unit) in Algeria and Exports (in Local Currency Unit) in South Sudan?
Provide a short and direct response. 5.24e+12. In the year 2014, what is the difference between the Exports (in Local Currency Unit) in Pakistan and Exports (in Local Currency Unit) in Serbia?
Your answer should be compact. 1.36e+12. In the year 2014, what is the difference between the Exports (in Local Currency Unit) of Pakistan and Exports (in Local Currency Unit) of South Sudan?
Offer a terse response. 3.07e+12. In the year 2014, what is the difference between the Exports (in Local Currency Unit) of Serbia and Exports (in Local Currency Unit) of South Sudan?
Your answer should be compact. 1.71e+12. What is the ratio of the Exports (in Local Currency Unit) in Algeria in 2009 to that in 2010?
Give a very brief answer. 0.76. What is the ratio of the Exports (in Local Currency Unit) in Pakistan in 2009 to that in 2010?
Make the answer very short. 0.81. What is the ratio of the Exports (in Local Currency Unit) of Serbia in 2009 to that in 2010?
Your answer should be compact. 0.77. What is the ratio of the Exports (in Local Currency Unit) of South Sudan in 2009 to that in 2010?
Offer a very short reply. 0.77. What is the ratio of the Exports (in Local Currency Unit) of Algeria in 2009 to that in 2011?
Provide a succinct answer. 0.62. What is the ratio of the Exports (in Local Currency Unit) in Pakistan in 2009 to that in 2011?
Your answer should be compact. 0.64. What is the ratio of the Exports (in Local Currency Unit) in Serbia in 2009 to that in 2011?
Your answer should be very brief. 0.67. What is the ratio of the Exports (in Local Currency Unit) of South Sudan in 2009 to that in 2011?
Your answer should be very brief. 0.48. What is the ratio of the Exports (in Local Currency Unit) in Algeria in 2009 to that in 2012?
Provide a short and direct response. 0.59. What is the ratio of the Exports (in Local Currency Unit) of Pakistan in 2009 to that in 2012?
Ensure brevity in your answer.  0.66. What is the ratio of the Exports (in Local Currency Unit) in Serbia in 2009 to that in 2012?
Ensure brevity in your answer.  0.58. What is the ratio of the Exports (in Local Currency Unit) of South Sudan in 2009 to that in 2012?
Your response must be concise. 5.5. What is the ratio of the Exports (in Local Currency Unit) of Algeria in 2009 to that in 2013?
Your answer should be compact. 0.64. What is the ratio of the Exports (in Local Currency Unit) of Pakistan in 2009 to that in 2013?
Give a very brief answer. 0.55. What is the ratio of the Exports (in Local Currency Unit) of Serbia in 2009 to that in 2013?
Offer a very short reply. 0.48. What is the ratio of the Exports (in Local Currency Unit) in South Sudan in 2009 to that in 2013?
Make the answer very short. 2.69. What is the ratio of the Exports (in Local Currency Unit) in Algeria in 2009 to that in 2014?
Offer a terse response. 0.67. What is the ratio of the Exports (in Local Currency Unit) in Pakistan in 2009 to that in 2014?
Make the answer very short. 0.53. What is the ratio of the Exports (in Local Currency Unit) in Serbia in 2009 to that in 2014?
Give a very brief answer. 0.45. What is the ratio of the Exports (in Local Currency Unit) in South Sudan in 2009 to that in 2014?
Ensure brevity in your answer.  2.16. What is the ratio of the Exports (in Local Currency Unit) in Algeria in 2010 to that in 2011?
Make the answer very short. 0.81. What is the ratio of the Exports (in Local Currency Unit) of Pakistan in 2010 to that in 2011?
Offer a very short reply. 0.79. What is the ratio of the Exports (in Local Currency Unit) in Serbia in 2010 to that in 2011?
Offer a terse response. 0.87. What is the ratio of the Exports (in Local Currency Unit) of South Sudan in 2010 to that in 2011?
Your response must be concise. 0.63. What is the ratio of the Exports (in Local Currency Unit) of Algeria in 2010 to that in 2012?
Your answer should be very brief. 0.77. What is the ratio of the Exports (in Local Currency Unit) in Pakistan in 2010 to that in 2012?
Give a very brief answer. 0.81. What is the ratio of the Exports (in Local Currency Unit) in Serbia in 2010 to that in 2012?
Ensure brevity in your answer.  0.76. What is the ratio of the Exports (in Local Currency Unit) in South Sudan in 2010 to that in 2012?
Your answer should be compact. 7.19. What is the ratio of the Exports (in Local Currency Unit) of Algeria in 2010 to that in 2013?
Your answer should be very brief. 0.83. What is the ratio of the Exports (in Local Currency Unit) in Pakistan in 2010 to that in 2013?
Ensure brevity in your answer.  0.68. What is the ratio of the Exports (in Local Currency Unit) in Serbia in 2010 to that in 2013?
Your response must be concise. 0.63. What is the ratio of the Exports (in Local Currency Unit) of South Sudan in 2010 to that in 2013?
Give a very brief answer. 3.52. What is the ratio of the Exports (in Local Currency Unit) of Algeria in 2010 to that in 2014?
Your answer should be compact. 0.88. What is the ratio of the Exports (in Local Currency Unit) of Pakistan in 2010 to that in 2014?
Keep it short and to the point. 0.65. What is the ratio of the Exports (in Local Currency Unit) of Serbia in 2010 to that in 2014?
Your answer should be very brief. 0.59. What is the ratio of the Exports (in Local Currency Unit) in South Sudan in 2010 to that in 2014?
Give a very brief answer. 2.82. What is the ratio of the Exports (in Local Currency Unit) in Algeria in 2011 to that in 2012?
Provide a short and direct response. 0.95. What is the ratio of the Exports (in Local Currency Unit) in Pakistan in 2011 to that in 2012?
Ensure brevity in your answer.  1.03. What is the ratio of the Exports (in Local Currency Unit) of Serbia in 2011 to that in 2012?
Offer a terse response. 0.87. What is the ratio of the Exports (in Local Currency Unit) of South Sudan in 2011 to that in 2012?
Offer a very short reply. 11.37. What is the ratio of the Exports (in Local Currency Unit) of Algeria in 2011 to that in 2013?
Offer a very short reply. 1.02. What is the ratio of the Exports (in Local Currency Unit) in Pakistan in 2011 to that in 2013?
Your response must be concise. 0.86. What is the ratio of the Exports (in Local Currency Unit) of Serbia in 2011 to that in 2013?
Your response must be concise. 0.72. What is the ratio of the Exports (in Local Currency Unit) of South Sudan in 2011 to that in 2013?
Offer a very short reply. 5.56. What is the ratio of the Exports (in Local Currency Unit) in Algeria in 2011 to that in 2014?
Offer a terse response. 1.08. What is the ratio of the Exports (in Local Currency Unit) of Pakistan in 2011 to that in 2014?
Offer a terse response. 0.83. What is the ratio of the Exports (in Local Currency Unit) in Serbia in 2011 to that in 2014?
Offer a terse response. 0.67. What is the ratio of the Exports (in Local Currency Unit) of South Sudan in 2011 to that in 2014?
Offer a very short reply. 4.46. What is the ratio of the Exports (in Local Currency Unit) of Algeria in 2012 to that in 2013?
Ensure brevity in your answer.  1.08. What is the ratio of the Exports (in Local Currency Unit) in Pakistan in 2012 to that in 2013?
Keep it short and to the point. 0.84. What is the ratio of the Exports (in Local Currency Unit) of Serbia in 2012 to that in 2013?
Offer a terse response. 0.83. What is the ratio of the Exports (in Local Currency Unit) of South Sudan in 2012 to that in 2013?
Provide a succinct answer. 0.49. What is the ratio of the Exports (in Local Currency Unit) in Algeria in 2012 to that in 2014?
Provide a short and direct response. 1.14. What is the ratio of the Exports (in Local Currency Unit) of Pakistan in 2012 to that in 2014?
Your answer should be compact. 0.81. What is the ratio of the Exports (in Local Currency Unit) in Serbia in 2012 to that in 2014?
Provide a succinct answer. 0.77. What is the ratio of the Exports (in Local Currency Unit) in South Sudan in 2012 to that in 2014?
Your answer should be very brief. 0.39. What is the ratio of the Exports (in Local Currency Unit) in Algeria in 2013 to that in 2014?
Your response must be concise. 1.05. What is the ratio of the Exports (in Local Currency Unit) in Pakistan in 2013 to that in 2014?
Keep it short and to the point. 0.97. What is the ratio of the Exports (in Local Currency Unit) in Serbia in 2013 to that in 2014?
Keep it short and to the point. 0.93. What is the ratio of the Exports (in Local Currency Unit) of South Sudan in 2013 to that in 2014?
Provide a short and direct response. 0.8. What is the difference between the highest and the second highest Exports (in Local Currency Unit) in Algeria?
Offer a terse response. 3.21e+11. What is the difference between the highest and the second highest Exports (in Local Currency Unit) in Pakistan?
Make the answer very short. 1.05e+11. What is the difference between the highest and the second highest Exports (in Local Currency Unit) in Serbia?
Provide a succinct answer. 1.22e+11. What is the difference between the highest and the second highest Exports (in Local Currency Unit) of South Sudan?
Provide a short and direct response. 1.29e+1. What is the difference between the highest and the lowest Exports (in Local Currency Unit) in Algeria?
Give a very brief answer. 2.45e+12. What is the difference between the highest and the lowest Exports (in Local Currency Unit) in Pakistan?
Offer a terse response. 1.44e+12. What is the difference between the highest and the lowest Exports (in Local Currency Unit) of Serbia?
Your answer should be very brief. 9.46e+11. What is the difference between the highest and the lowest Exports (in Local Currency Unit) in South Sudan?
Keep it short and to the point. 3.21e+1. 